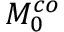<formula> <loc_0><loc_0><loc_500><loc_500>M _ { 0 } ^ { c o }</formula> 